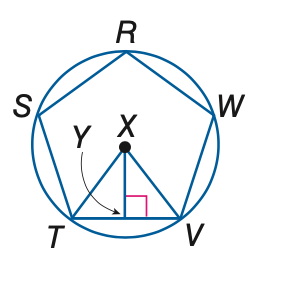Question: In the figure, a regular polygon is inscribed in a circle. Find the measure of a central angle.
Choices:
A. 18
B. 36
C. 72
D. 144
Answer with the letter. Answer: C 